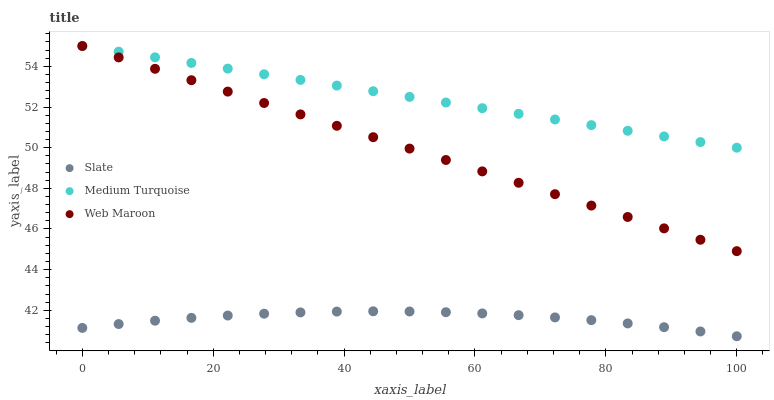Does Slate have the minimum area under the curve?
Answer yes or no. Yes. Does Medium Turquoise have the maximum area under the curve?
Answer yes or no. Yes. Does Web Maroon have the minimum area under the curve?
Answer yes or no. No. Does Web Maroon have the maximum area under the curve?
Answer yes or no. No. Is Web Maroon the smoothest?
Answer yes or no. Yes. Is Slate the roughest?
Answer yes or no. Yes. Is Medium Turquoise the smoothest?
Answer yes or no. No. Is Medium Turquoise the roughest?
Answer yes or no. No. Does Slate have the lowest value?
Answer yes or no. Yes. Does Web Maroon have the lowest value?
Answer yes or no. No. Does Medium Turquoise have the highest value?
Answer yes or no. Yes. Is Slate less than Medium Turquoise?
Answer yes or no. Yes. Is Web Maroon greater than Slate?
Answer yes or no. Yes. Does Medium Turquoise intersect Web Maroon?
Answer yes or no. Yes. Is Medium Turquoise less than Web Maroon?
Answer yes or no. No. Is Medium Turquoise greater than Web Maroon?
Answer yes or no. No. Does Slate intersect Medium Turquoise?
Answer yes or no. No. 